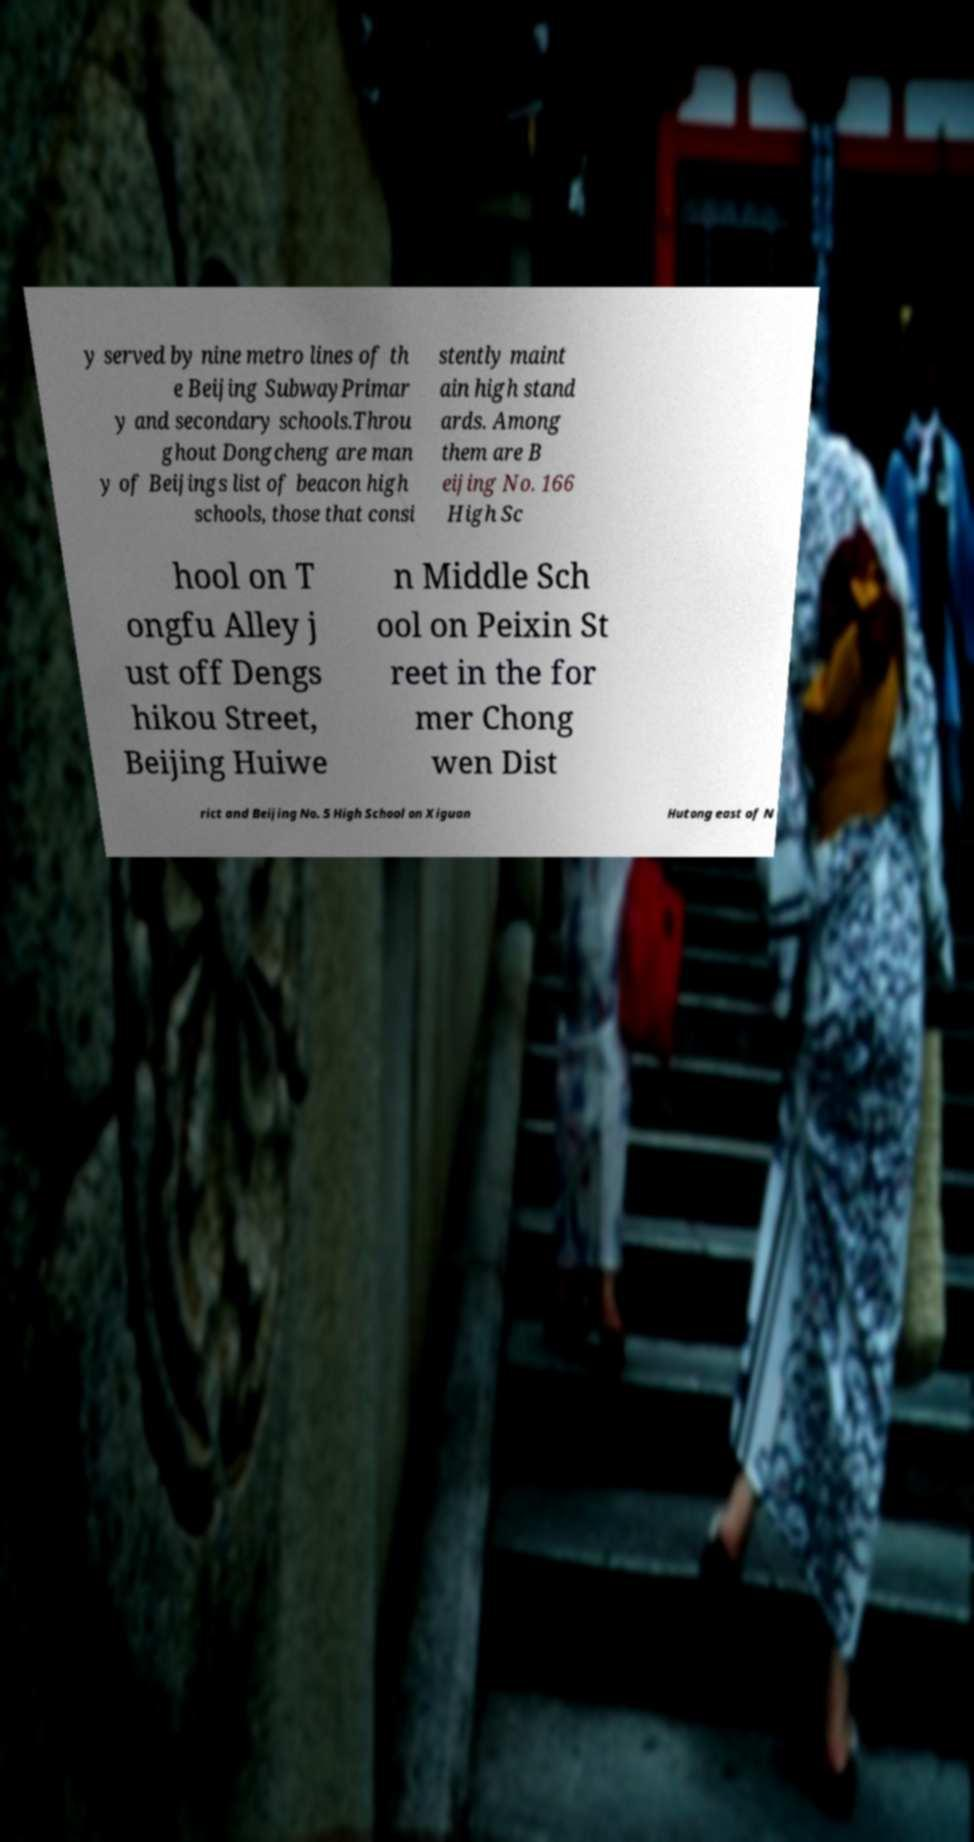Please identify and transcribe the text found in this image. y served by nine metro lines of th e Beijing SubwayPrimar y and secondary schools.Throu ghout Dongcheng are man y of Beijings list of beacon high schools, those that consi stently maint ain high stand ards. Among them are B eijing No. 166 High Sc hool on T ongfu Alley j ust off Dengs hikou Street, Beijing Huiwe n Middle Sch ool on Peixin St reet in the for mer Chong wen Dist rict and Beijing No. 5 High School on Xiguan Hutong east of N 